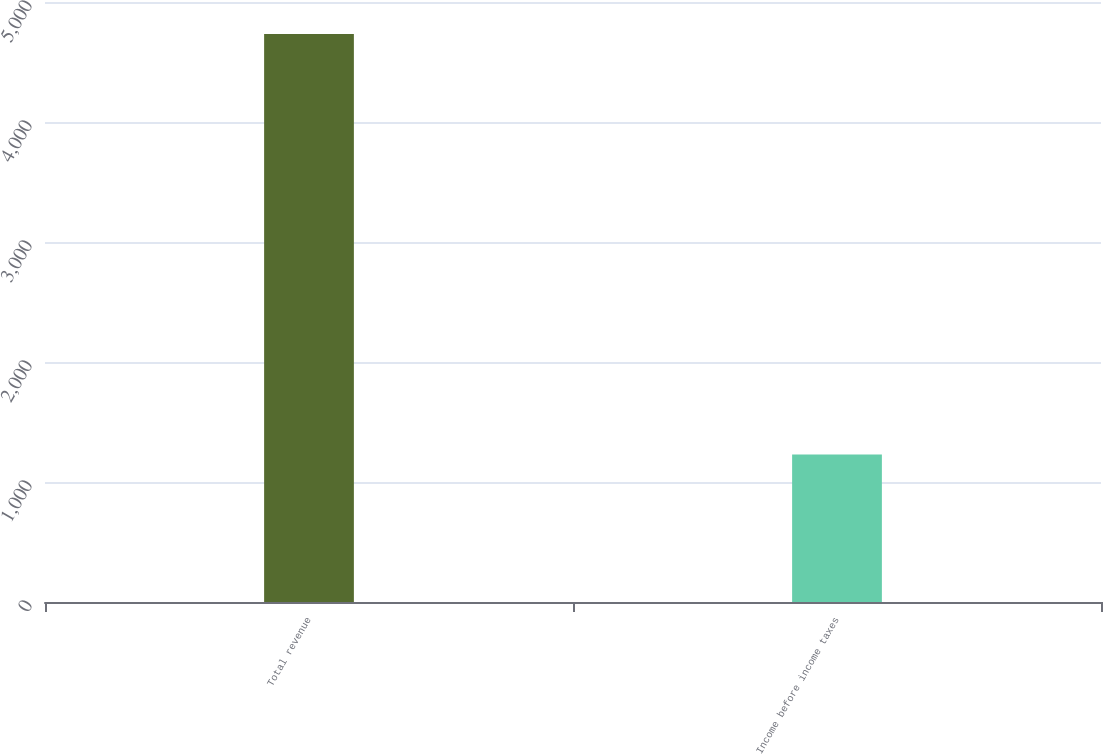Convert chart to OTSL. <chart><loc_0><loc_0><loc_500><loc_500><bar_chart><fcel>Total revenue<fcel>Income before income taxes<nl><fcel>4734<fcel>1230<nl></chart> 